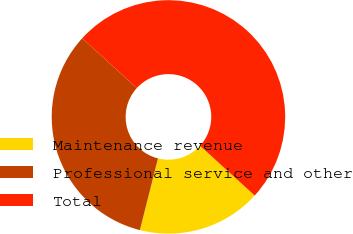Convert chart. <chart><loc_0><loc_0><loc_500><loc_500><pie_chart><fcel>Maintenance revenue<fcel>Professional service and other<fcel>Total<nl><fcel>17.17%<fcel>32.83%<fcel>50.0%<nl></chart> 